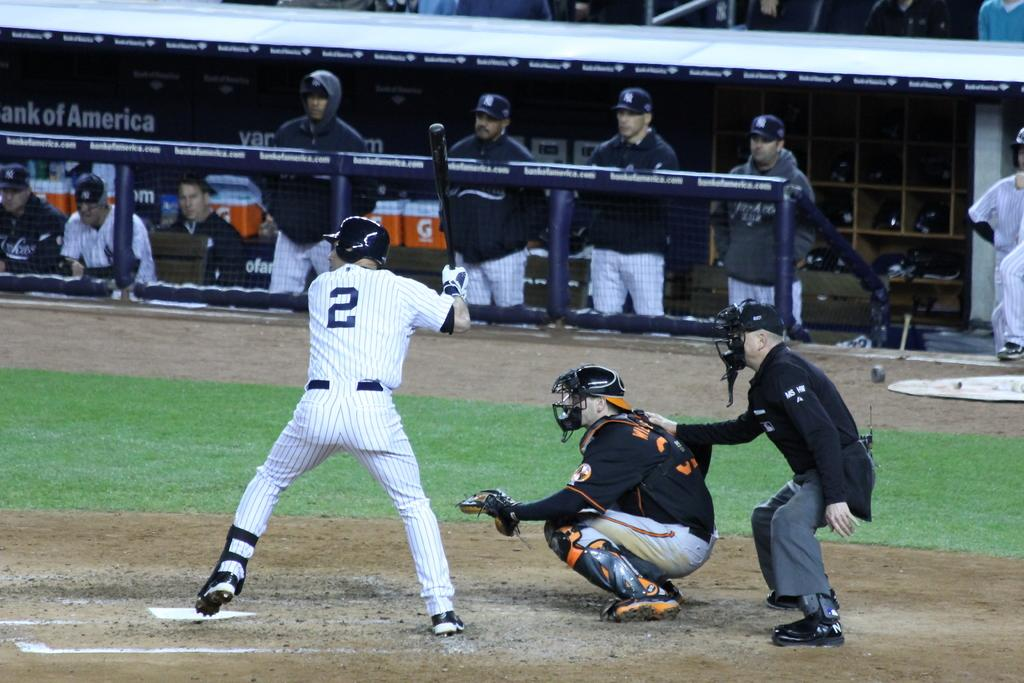<image>
Describe the image concisely. a player with the number 2 on their jersey is getting ready to hit 